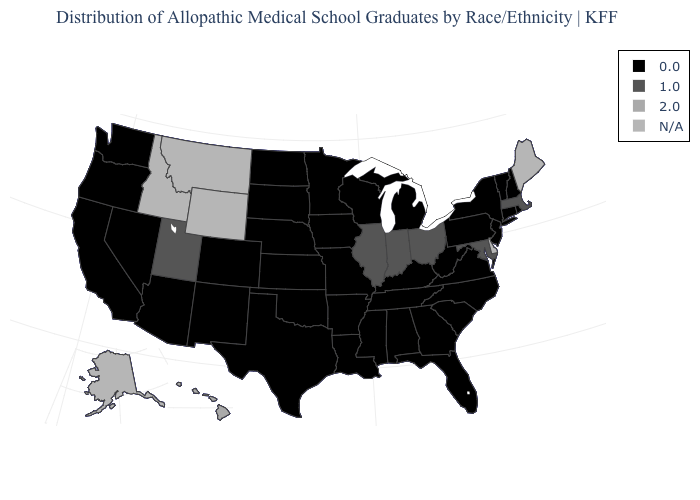What is the value of Pennsylvania?
Write a very short answer. 0.0. What is the value of North Dakota?
Answer briefly. 0.0. Name the states that have a value in the range 1.0?
Answer briefly. Illinois, Indiana, Maryland, Massachusetts, Ohio, Utah. What is the lowest value in states that border Florida?
Short answer required. 0.0. Name the states that have a value in the range 2.0?
Quick response, please. Hawaii. Does Indiana have the highest value in the MidWest?
Short answer required. Yes. How many symbols are there in the legend?
Give a very brief answer. 4. What is the value of Connecticut?
Be succinct. 0.0. Name the states that have a value in the range 0.0?
Quick response, please. Alabama, Arizona, Arkansas, California, Colorado, Connecticut, Florida, Georgia, Iowa, Kansas, Kentucky, Louisiana, Michigan, Minnesota, Mississippi, Missouri, Nebraska, Nevada, New Hampshire, New Jersey, New Mexico, New York, North Carolina, North Dakota, Oklahoma, Oregon, Pennsylvania, Rhode Island, South Carolina, South Dakota, Tennessee, Texas, Vermont, Virginia, Washington, West Virginia, Wisconsin. Does Massachusetts have the lowest value in the Northeast?
Concise answer only. No. What is the lowest value in the MidWest?
Concise answer only. 0.0. Name the states that have a value in the range 2.0?
Quick response, please. Hawaii. What is the value of Colorado?
Concise answer only. 0.0. Which states have the highest value in the USA?
Answer briefly. Hawaii. What is the value of Alaska?
Answer briefly. N/A. 